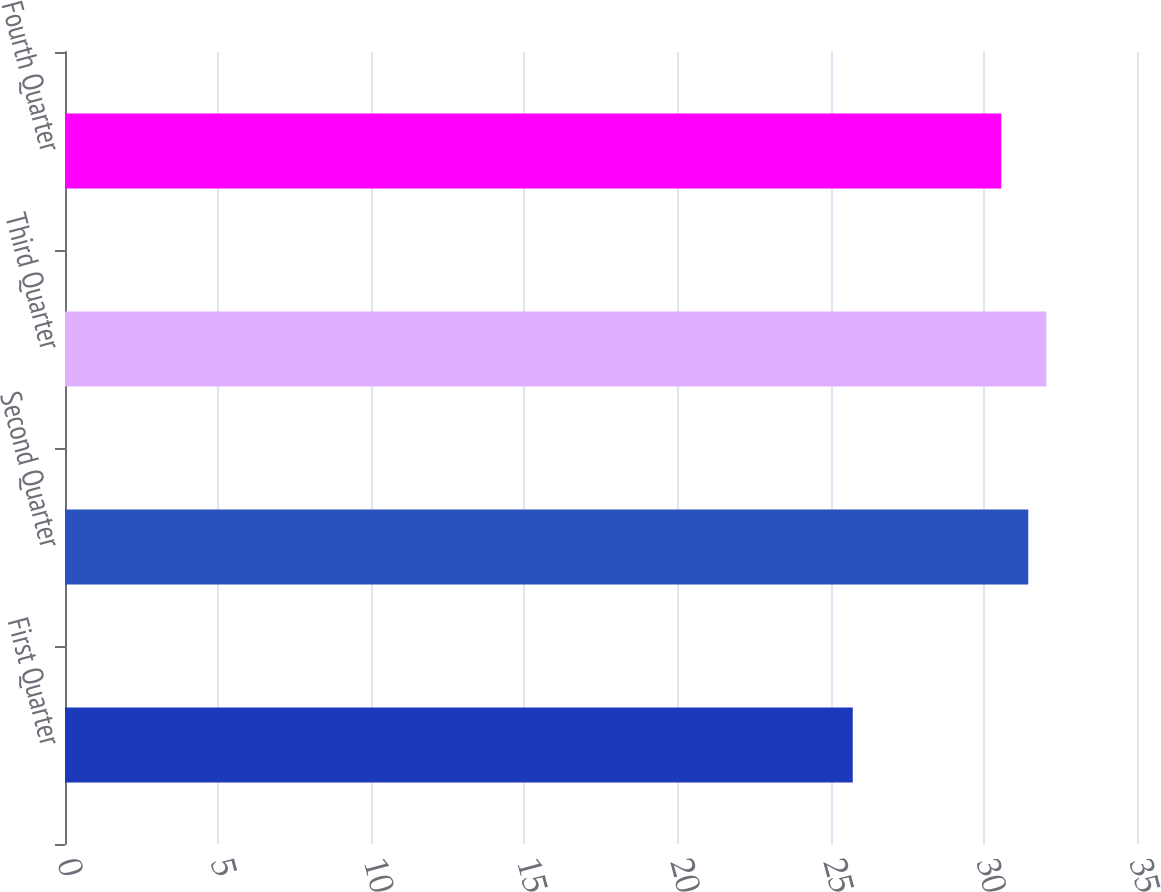Convert chart. <chart><loc_0><loc_0><loc_500><loc_500><bar_chart><fcel>First Quarter<fcel>Second Quarter<fcel>Third Quarter<fcel>Fourth Quarter<nl><fcel>25.72<fcel>31.45<fcel>32.04<fcel>30.57<nl></chart> 